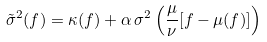Convert formula to latex. <formula><loc_0><loc_0><loc_500><loc_500>\tilde { \sigma } ^ { 2 } ( f ) = \kappa ( f ) + \alpha \, \sigma ^ { 2 } \left ( \frac { \mu } { \nu } [ f - \mu ( f ) ] \right )</formula> 